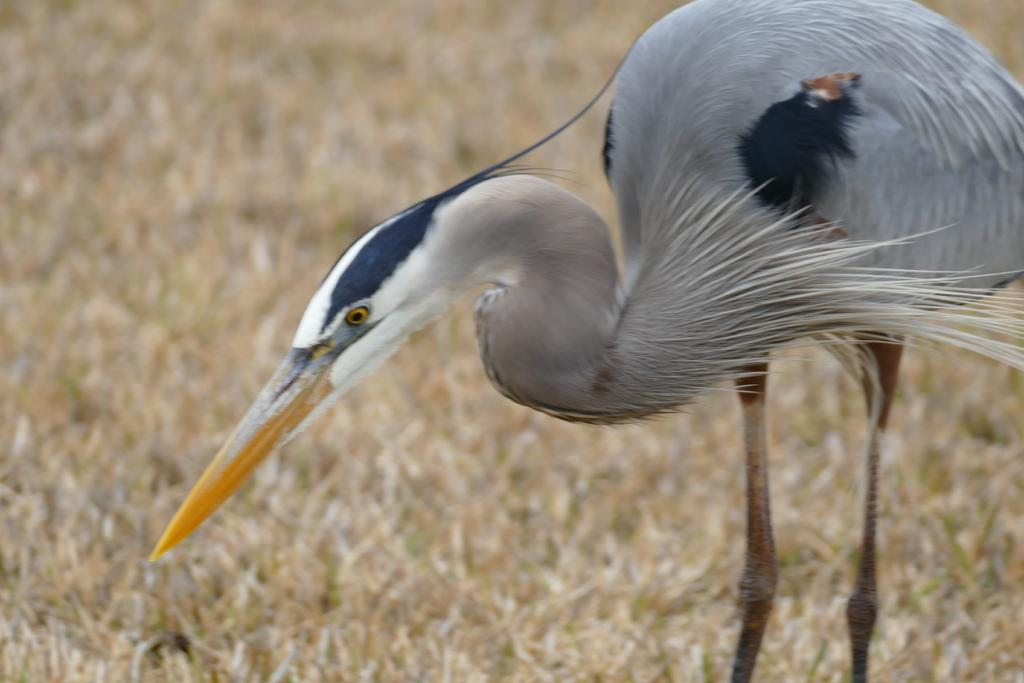What type of animal is in the image? There is a bird in the image. Can you describe the colors of the bird? The bird has white and gray colors. What can be seen in the background of the image? There is dried grass in the background of the image. How many minutes does the tramp take to complete a division problem in the image? There is no tramp or division problem present in the image; it features a bird and dried grass in the background. 